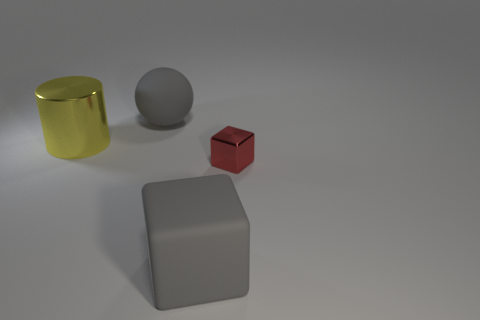Is there any other thing that has the same size as the red cube?
Ensure brevity in your answer.  No. The big gray thing that is made of the same material as the gray block is what shape?
Provide a short and direct response. Sphere. What number of other things are there of the same shape as the large yellow object?
Provide a succinct answer. 0. Does the gray object that is behind the gray cube have the same size as the large yellow metallic cylinder?
Your answer should be compact. Yes. Are there more gray matte objects that are in front of the yellow cylinder than brown metallic things?
Ensure brevity in your answer.  Yes. What number of matte objects are behind the matte thing that is in front of the big sphere?
Make the answer very short. 1. Are there fewer big gray rubber cubes that are behind the rubber cube than balls?
Offer a very short reply. Yes. There is a big matte thing that is left of the thing in front of the tiny red block; is there a large rubber thing in front of it?
Ensure brevity in your answer.  Yes. Does the ball have the same material as the big object in front of the cylinder?
Make the answer very short. Yes. What is the color of the thing that is in front of the metal thing in front of the large metallic cylinder?
Provide a short and direct response. Gray. 